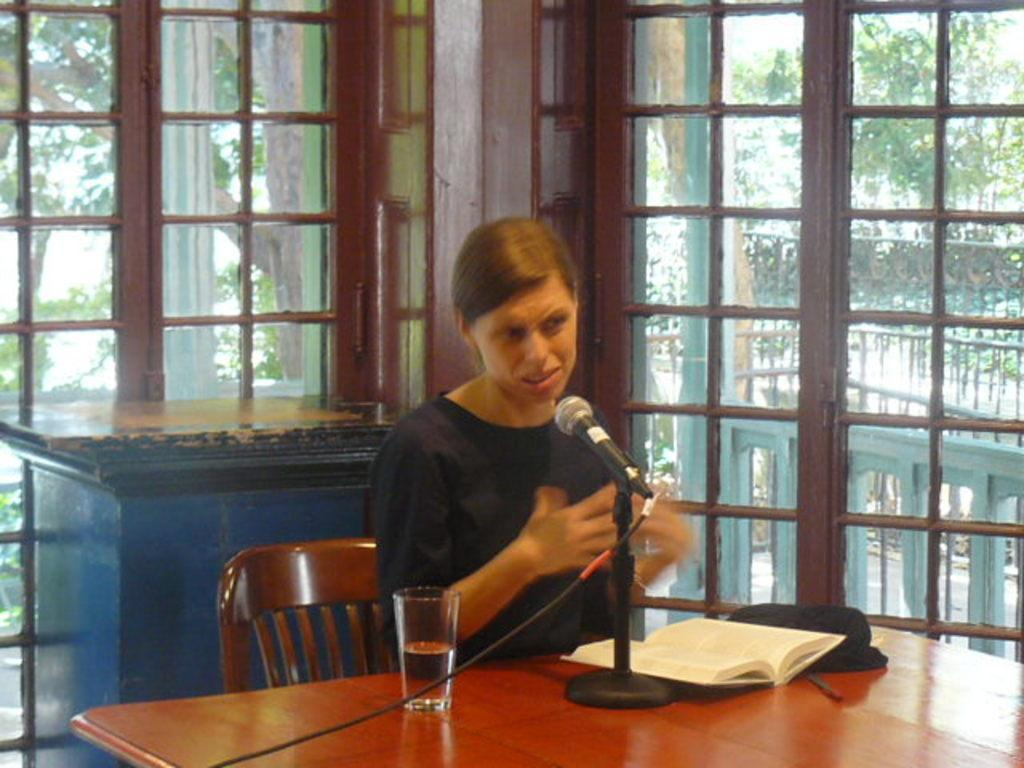What is the woman in the image doing? The woman is sitting on a chair in the image. What objects are on the table in front of the woman? There is a mic, a book, and a glass on the table in front of the woman. What can be seen in the background of the image? Windows and trees are visible in the background of the image. How many dinosaurs are visible in the image? There are no dinosaurs present in the image. What type of carriage is parked outside the window in the image? There is no carriage visible in the image; only windows and trees can be seen in the background. 